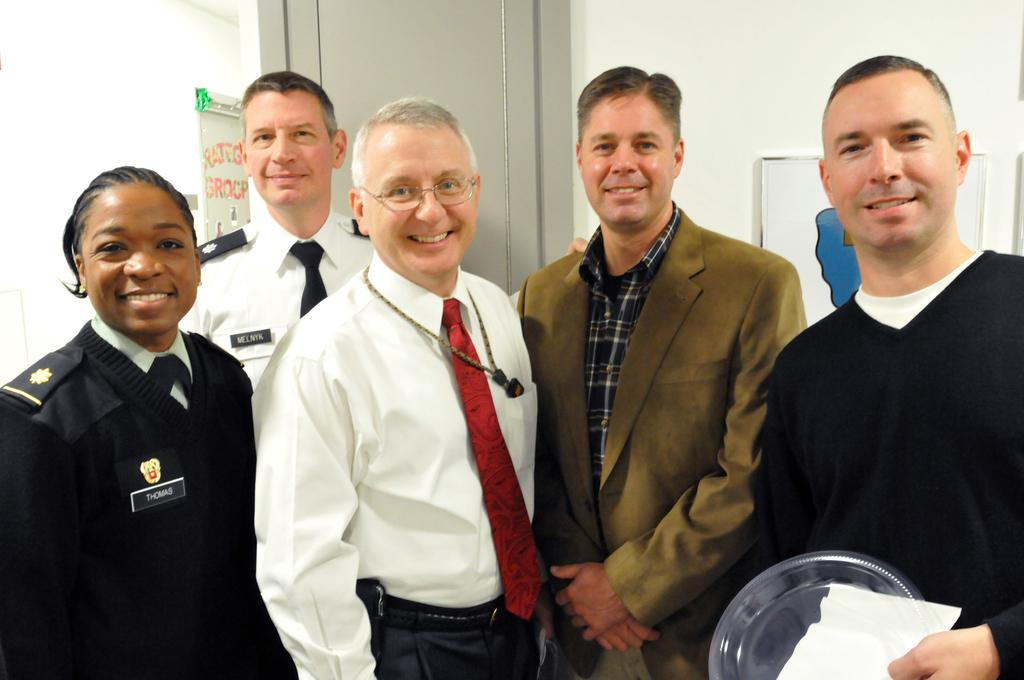How many people are in the image? There is a group of people in the image. What is the man holding in the image? The man is holding some objects. What can be seen in the background of the image? There is a door and a wall visible in the background, along with additional objects. How many toes does the sister have in the image? There is no sister present in the image, and therefore no toes to count. 